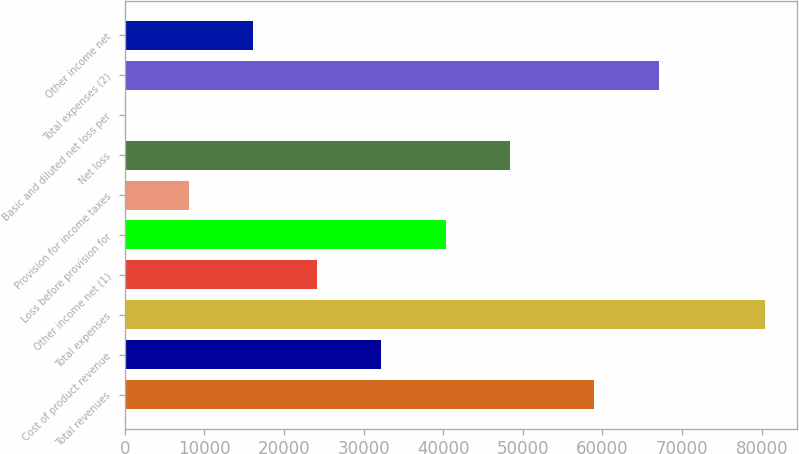Convert chart. <chart><loc_0><loc_0><loc_500><loc_500><bar_chart><fcel>Total revenues<fcel>Cost of product revenue<fcel>Total expenses<fcel>Other income net (1)<fcel>Loss before provision for<fcel>Provision for income taxes<fcel>Net loss<fcel>Basic and diluted net loss per<fcel>Total expenses (2)<fcel>Other income net<nl><fcel>58941<fcel>32145.9<fcel>80363<fcel>24109.8<fcel>40403<fcel>8037.43<fcel>48439.2<fcel>1.26<fcel>67148<fcel>16073.6<nl></chart> 